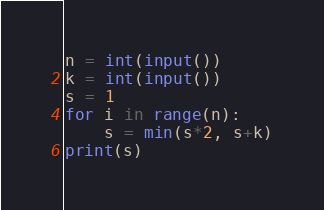Convert code to text. <code><loc_0><loc_0><loc_500><loc_500><_Python_>n = int(input())
k = int(input())
s = 1
for i in range(n):
    s = min(s*2, s+k)
print(s)</code> 